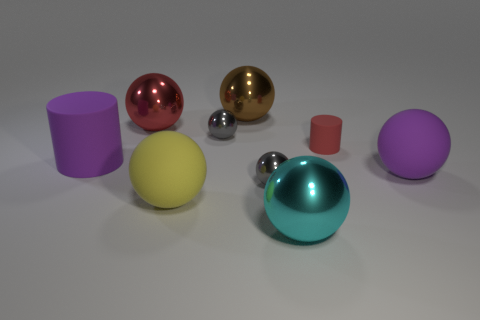Are there fewer tiny metallic objects that are on the left side of the purple cylinder than big cylinders on the right side of the red rubber cylinder?
Your answer should be very brief. No. How many other things are there of the same size as the brown metal sphere?
Keep it short and to the point. 5. Are the large brown ball and the red thing in front of the red ball made of the same material?
Your response must be concise. No. What number of objects are either tiny gray metal objects that are in front of the brown sphere or tiny gray metallic spheres in front of the tiny rubber cylinder?
Make the answer very short. 2. What is the color of the tiny rubber object?
Provide a short and direct response. Red. Is the number of big brown metallic objects right of the small red cylinder less than the number of tiny blue metal balls?
Offer a terse response. No. Is there anything else that is the same shape as the red metallic thing?
Your response must be concise. Yes. Are there any gray rubber cylinders?
Keep it short and to the point. No. Is the number of big gray metallic cylinders less than the number of rubber objects?
Your response must be concise. Yes. What number of other large spheres have the same material as the brown ball?
Ensure brevity in your answer.  2. 